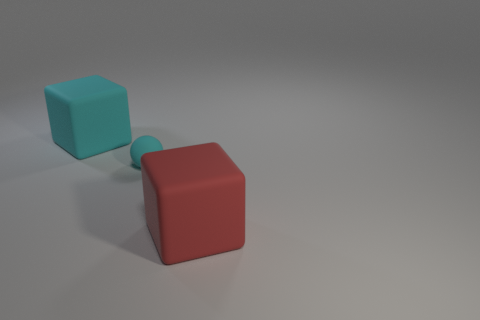Add 2 big cyan blocks. How many objects exist? 5 Subtract all blocks. How many objects are left? 1 Add 3 spheres. How many spheres are left? 4 Add 3 big cyan objects. How many big cyan objects exist? 4 Subtract 0 green cubes. How many objects are left? 3 Subtract all big cyan things. Subtract all big red objects. How many objects are left? 1 